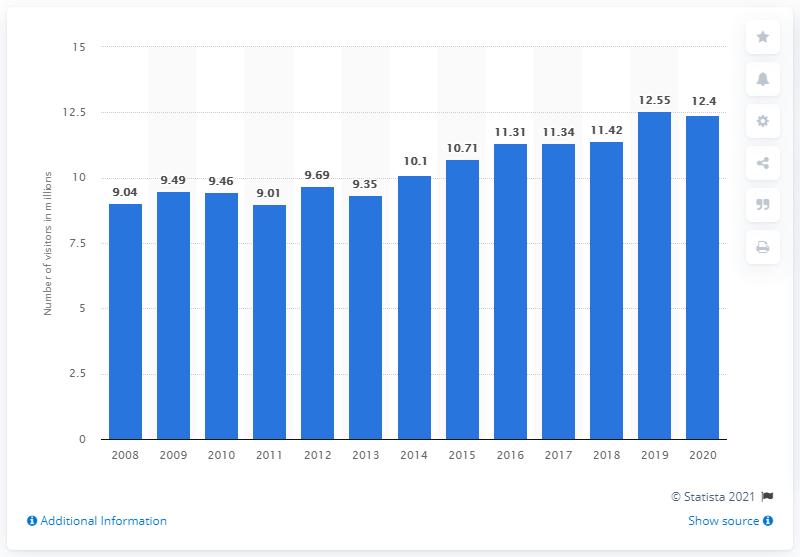Draw attention to some important aspects in this diagram. In 2020, the Great Smoky Mountains National Park welcomed a total of 12,400,000 visitors. 